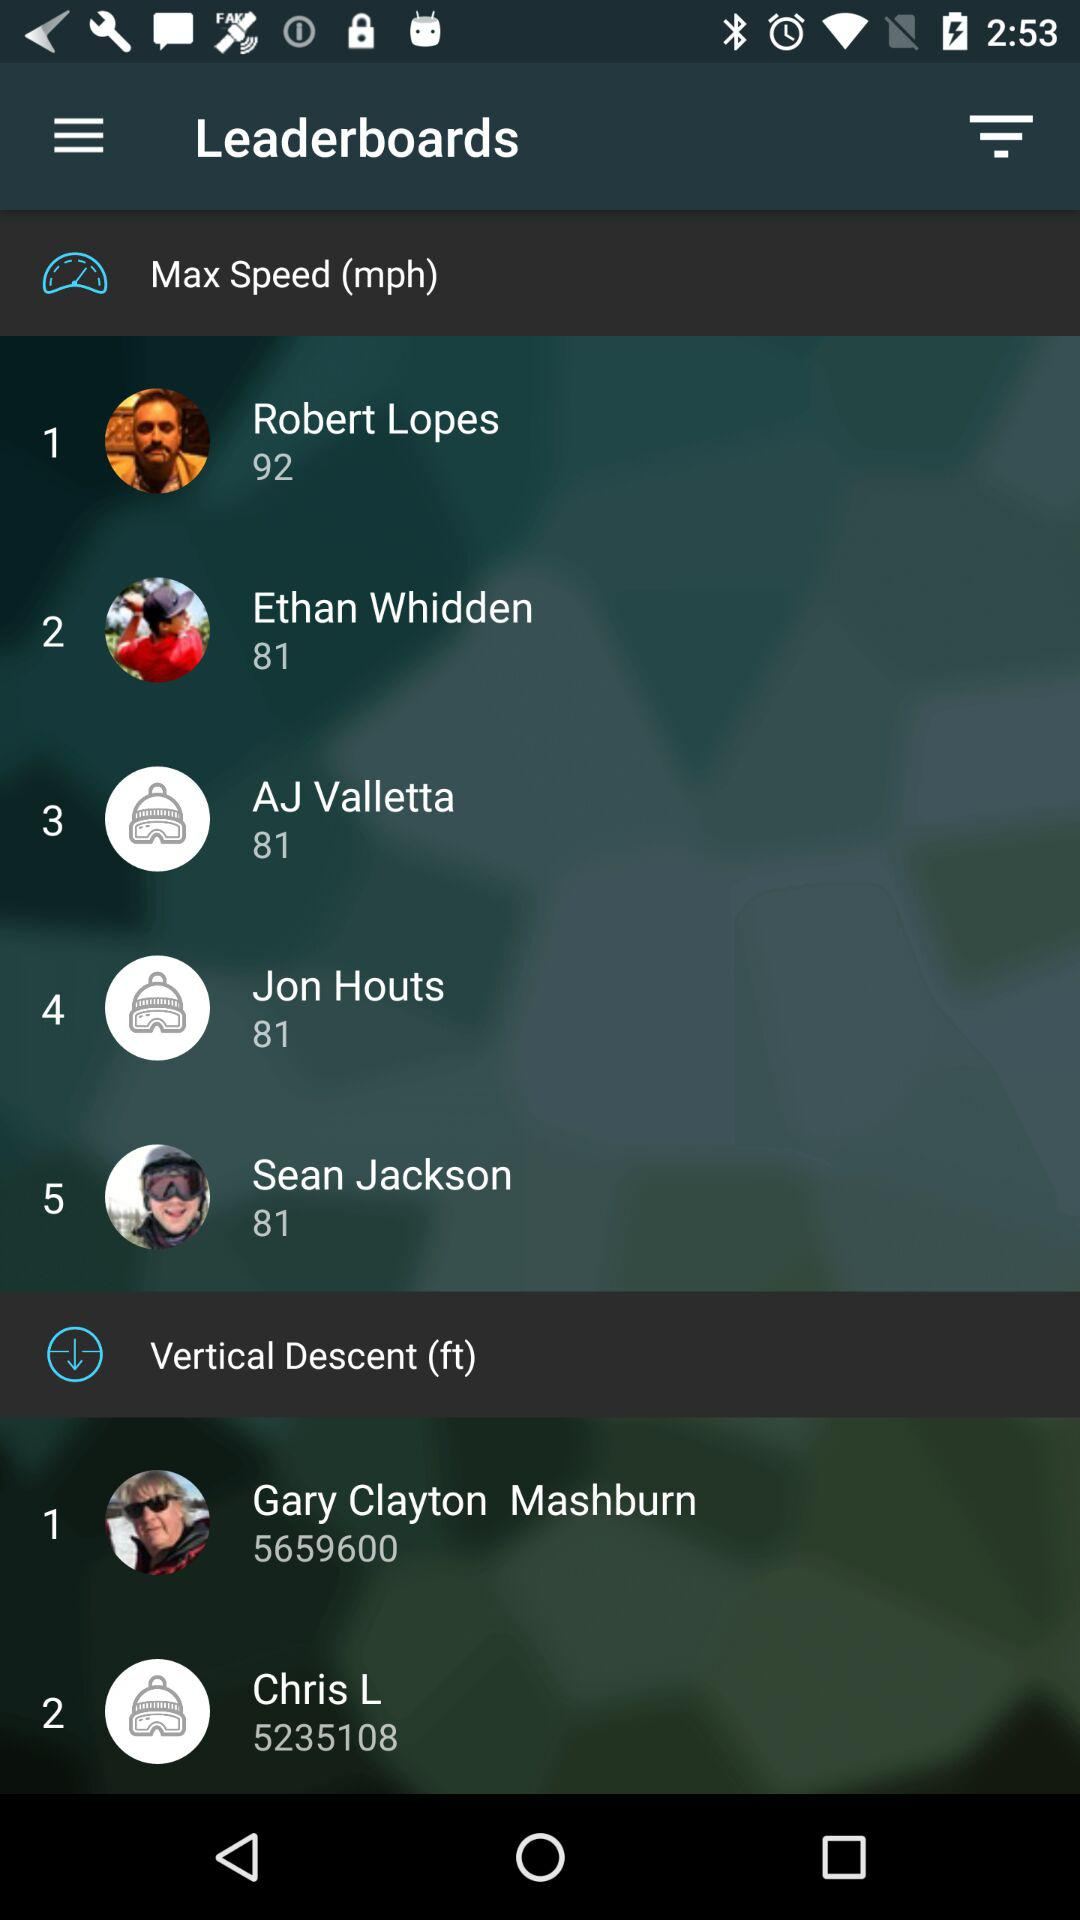What is the score of Robert Lopes? The score of Robert Lopes is 92. 